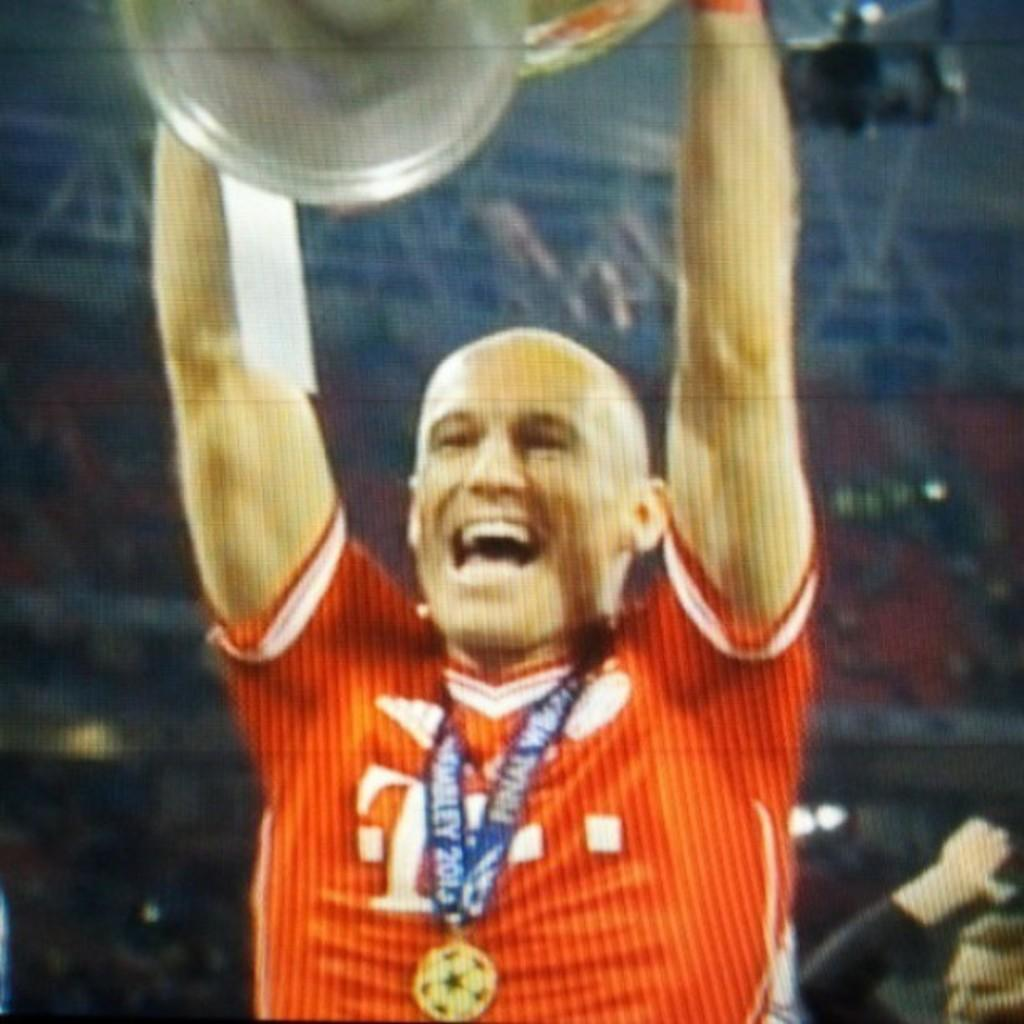What is the man in the image doing? The man is standing in the image. What is the man holding in his hands? The man is holding an object in his hands. Can you describe the man's attire? The man is wearing a medal and a jersey. Is there anyone else in the image besides the man? Yes, there is another man in the background of the image. What else can be seen in the background of the image? There are other objects visible in the background of the image. What type of loaf is the man cooking in the image? There is no loaf or cooking activity present in the image. What news is the man reading in the image? There is no newspaper or reading activity present in the image. 